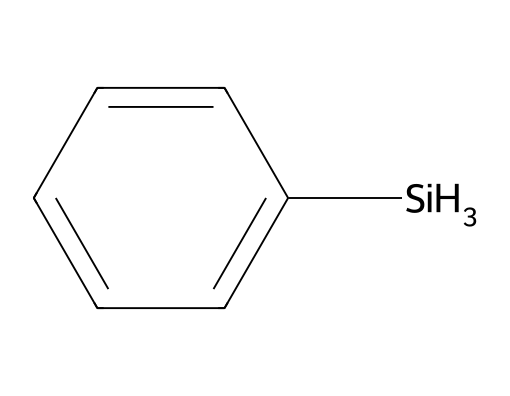What is the molecular formula of phenylsilane? The structure contains 6 carbon atoms from the phenyl group (c1ccccc1), 1 silicon atom (from [SiH3]), and 7 hydrogen atoms (3 from the silane and 4 from the phenyl hydrogen). Therefore, the molecular formula is C6H7Si.
Answer: C6H7Si How many hydrogen atoms are attached to silicon in phenylsilane? The [SiH3] indicates that there are 3 hydrogen atoms attached to the silicon atom in phenylsilane.
Answer: 3 What type of bonding occurs between the silicon and hydrogen in phenylsilane? The bonding between silicon and hydrogen in the [SiH3] indicates that it is a covalent bond, which is typical for silanes as they form strong bonds with hydrogen atoms.
Answer: covalent What is the hybridization of the silicon atom in phenylsilane? The silicon atom in phenylsilane forms four bonds: three with hydrogen and one with the phenyl group, resulting in tetrahedral geometry. Thus, the hybridization is sp3.
Answer: sp3 Which part of the molecule contributes to its aromaticity? The 'c1ccccc1' part of the SMILES structure represents a benzene ring, which contains delocalized electrons and satisfies Huckel's rule, thus providing aromaticity.
Answer: benzene ring What role does phenylsilane often play in chemical synthesis? Phenylsilane serves as a precursor in organic synthesis for creating silicon-containing compounds or as a reagent in various chemical reactions.
Answer: precursor What type of silane is phenylsilane classified as? Phenylsilane is classified as an arylsilane due to the presence of the phenyl group attached to the silicon atom.
Answer: arylsilane 